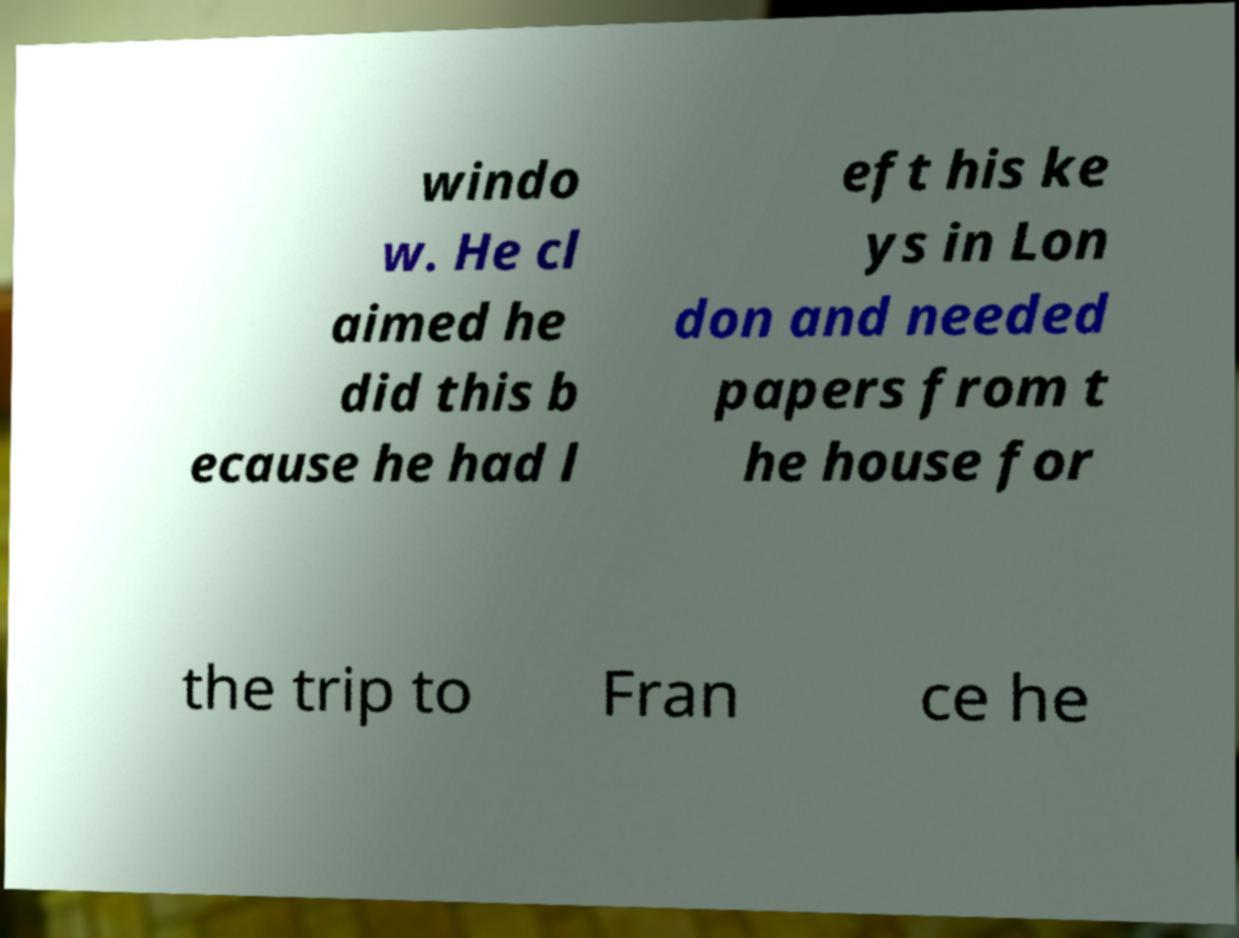Can you read and provide the text displayed in the image?This photo seems to have some interesting text. Can you extract and type it out for me? windo w. He cl aimed he did this b ecause he had l eft his ke ys in Lon don and needed papers from t he house for the trip to Fran ce he 